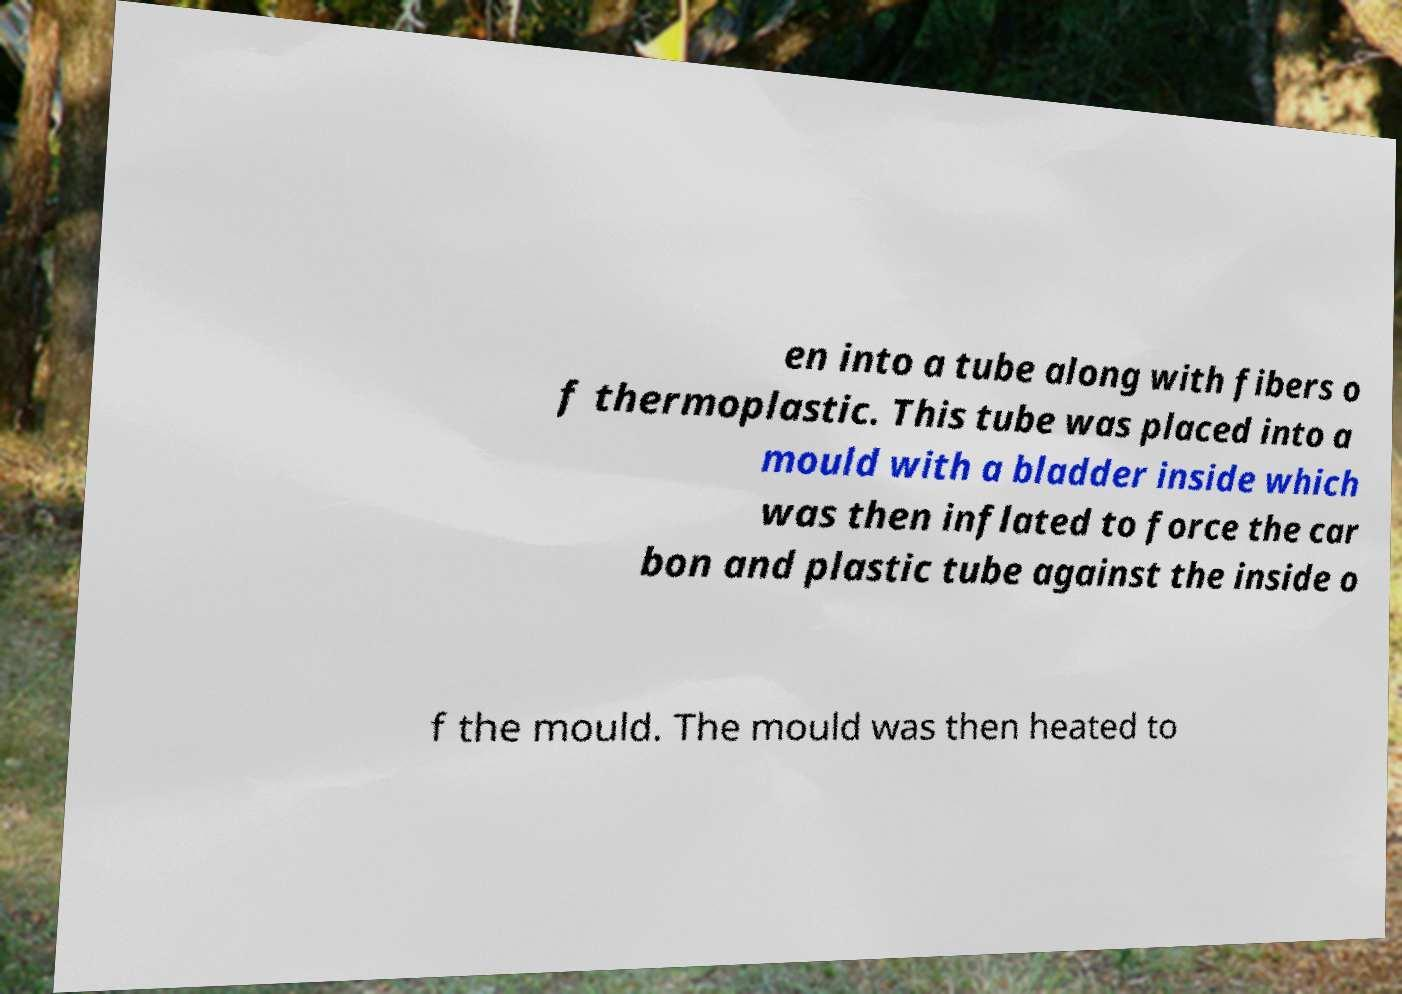What messages or text are displayed in this image? I need them in a readable, typed format. en into a tube along with fibers o f thermoplastic. This tube was placed into a mould with a bladder inside which was then inflated to force the car bon and plastic tube against the inside o f the mould. The mould was then heated to 